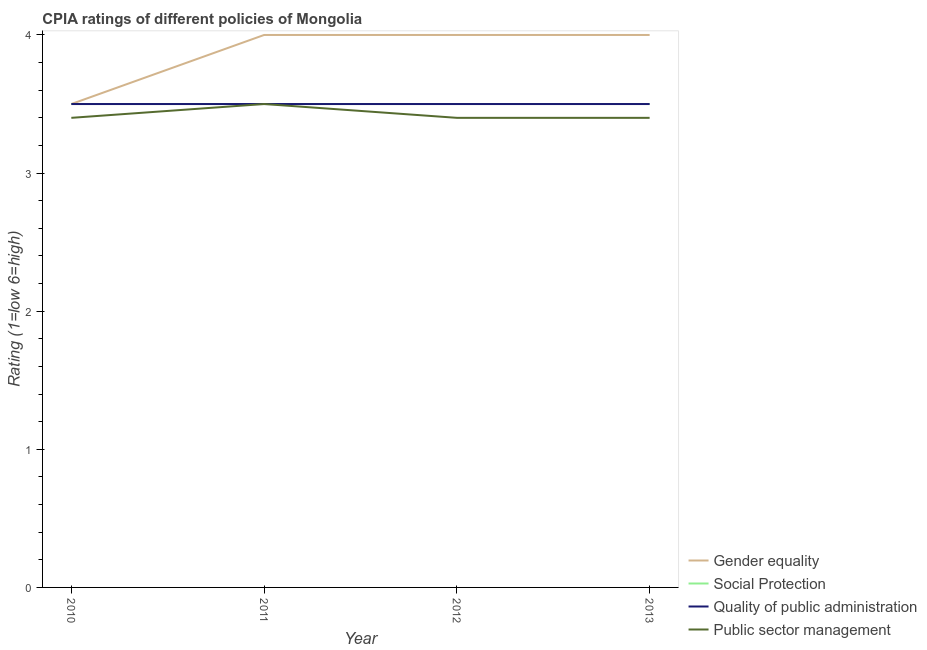How many different coloured lines are there?
Offer a terse response. 4. Across all years, what is the maximum cpia rating of gender equality?
Give a very brief answer. 4. In which year was the cpia rating of public sector management maximum?
Provide a succinct answer. 2011. In which year was the cpia rating of gender equality minimum?
Ensure brevity in your answer.  2010. What is the total cpia rating of gender equality in the graph?
Make the answer very short. 15.5. What is the difference between the cpia rating of public sector management in 2012 and the cpia rating of social protection in 2013?
Offer a terse response. -0.1. In the year 2010, what is the difference between the cpia rating of social protection and cpia rating of quality of public administration?
Your answer should be very brief. 0. What is the difference between the highest and the second highest cpia rating of quality of public administration?
Keep it short and to the point. 0. Is the sum of the cpia rating of public sector management in 2010 and 2013 greater than the maximum cpia rating of gender equality across all years?
Give a very brief answer. Yes. Is it the case that in every year, the sum of the cpia rating of gender equality and cpia rating of social protection is greater than the cpia rating of quality of public administration?
Provide a short and direct response. Yes. Is the cpia rating of social protection strictly greater than the cpia rating of gender equality over the years?
Offer a terse response. No. What is the difference between two consecutive major ticks on the Y-axis?
Your answer should be very brief. 1. Are the values on the major ticks of Y-axis written in scientific E-notation?
Provide a short and direct response. No. Does the graph contain any zero values?
Keep it short and to the point. No. What is the title of the graph?
Make the answer very short. CPIA ratings of different policies of Mongolia. What is the label or title of the X-axis?
Provide a short and direct response. Year. What is the label or title of the Y-axis?
Make the answer very short. Rating (1=low 6=high). What is the Rating (1=low 6=high) in Gender equality in 2010?
Give a very brief answer. 3.5. What is the Rating (1=low 6=high) of Social Protection in 2010?
Provide a short and direct response. 3.5. What is the Rating (1=low 6=high) in Public sector management in 2010?
Keep it short and to the point. 3.4. What is the Rating (1=low 6=high) in Public sector management in 2011?
Make the answer very short. 3.5. What is the Rating (1=low 6=high) in Social Protection in 2012?
Keep it short and to the point. 3.5. What is the Rating (1=low 6=high) in Quality of public administration in 2012?
Offer a terse response. 3.5. What is the Rating (1=low 6=high) of Gender equality in 2013?
Give a very brief answer. 4. What is the Rating (1=low 6=high) of Social Protection in 2013?
Ensure brevity in your answer.  3.5. Across all years, what is the maximum Rating (1=low 6=high) of Gender equality?
Your answer should be compact. 4. Across all years, what is the maximum Rating (1=low 6=high) in Quality of public administration?
Keep it short and to the point. 3.5. Across all years, what is the maximum Rating (1=low 6=high) of Public sector management?
Provide a short and direct response. 3.5. Across all years, what is the minimum Rating (1=low 6=high) of Gender equality?
Ensure brevity in your answer.  3.5. What is the total Rating (1=low 6=high) in Gender equality in the graph?
Ensure brevity in your answer.  15.5. What is the total Rating (1=low 6=high) of Social Protection in the graph?
Your answer should be very brief. 14. What is the total Rating (1=low 6=high) of Quality of public administration in the graph?
Ensure brevity in your answer.  14. What is the total Rating (1=low 6=high) in Public sector management in the graph?
Your answer should be compact. 13.7. What is the difference between the Rating (1=low 6=high) in Social Protection in 2010 and that in 2011?
Give a very brief answer. 0. What is the difference between the Rating (1=low 6=high) in Quality of public administration in 2010 and that in 2011?
Provide a short and direct response. 0. What is the difference between the Rating (1=low 6=high) in Gender equality in 2010 and that in 2012?
Your answer should be very brief. -0.5. What is the difference between the Rating (1=low 6=high) of Social Protection in 2010 and that in 2012?
Your response must be concise. 0. What is the difference between the Rating (1=low 6=high) in Quality of public administration in 2010 and that in 2012?
Ensure brevity in your answer.  0. What is the difference between the Rating (1=low 6=high) in Quality of public administration in 2010 and that in 2013?
Give a very brief answer. 0. What is the difference between the Rating (1=low 6=high) in Gender equality in 2011 and that in 2012?
Make the answer very short. 0. What is the difference between the Rating (1=low 6=high) of Public sector management in 2011 and that in 2012?
Ensure brevity in your answer.  0.1. What is the difference between the Rating (1=low 6=high) of Gender equality in 2011 and that in 2013?
Ensure brevity in your answer.  0. What is the difference between the Rating (1=low 6=high) in Social Protection in 2011 and that in 2013?
Make the answer very short. 0. What is the difference between the Rating (1=low 6=high) in Quality of public administration in 2011 and that in 2013?
Ensure brevity in your answer.  0. What is the difference between the Rating (1=low 6=high) in Public sector management in 2011 and that in 2013?
Your response must be concise. 0.1. What is the difference between the Rating (1=low 6=high) in Social Protection in 2012 and that in 2013?
Your response must be concise. 0. What is the difference between the Rating (1=low 6=high) in Social Protection in 2010 and the Rating (1=low 6=high) in Quality of public administration in 2011?
Offer a terse response. 0. What is the difference between the Rating (1=low 6=high) in Social Protection in 2010 and the Rating (1=low 6=high) in Public sector management in 2011?
Offer a terse response. 0. What is the difference between the Rating (1=low 6=high) of Gender equality in 2010 and the Rating (1=low 6=high) of Social Protection in 2012?
Offer a very short reply. 0. What is the difference between the Rating (1=low 6=high) of Gender equality in 2010 and the Rating (1=low 6=high) of Quality of public administration in 2012?
Provide a succinct answer. 0. What is the difference between the Rating (1=low 6=high) of Social Protection in 2010 and the Rating (1=low 6=high) of Quality of public administration in 2012?
Provide a succinct answer. 0. What is the difference between the Rating (1=low 6=high) in Quality of public administration in 2010 and the Rating (1=low 6=high) in Public sector management in 2012?
Make the answer very short. 0.1. What is the difference between the Rating (1=low 6=high) in Gender equality in 2010 and the Rating (1=low 6=high) in Social Protection in 2013?
Offer a very short reply. 0. What is the difference between the Rating (1=low 6=high) in Gender equality in 2010 and the Rating (1=low 6=high) in Quality of public administration in 2013?
Make the answer very short. 0. What is the difference between the Rating (1=low 6=high) of Social Protection in 2010 and the Rating (1=low 6=high) of Quality of public administration in 2013?
Offer a very short reply. 0. What is the difference between the Rating (1=low 6=high) of Gender equality in 2011 and the Rating (1=low 6=high) of Social Protection in 2012?
Offer a terse response. 0.5. What is the difference between the Rating (1=low 6=high) in Gender equality in 2011 and the Rating (1=low 6=high) in Quality of public administration in 2012?
Offer a terse response. 0.5. What is the difference between the Rating (1=low 6=high) of Social Protection in 2011 and the Rating (1=low 6=high) of Quality of public administration in 2012?
Your response must be concise. 0. What is the difference between the Rating (1=low 6=high) in Quality of public administration in 2011 and the Rating (1=low 6=high) in Public sector management in 2012?
Give a very brief answer. 0.1. What is the difference between the Rating (1=low 6=high) of Gender equality in 2011 and the Rating (1=low 6=high) of Social Protection in 2013?
Make the answer very short. 0.5. What is the difference between the Rating (1=low 6=high) in Gender equality in 2011 and the Rating (1=low 6=high) in Quality of public administration in 2013?
Offer a very short reply. 0.5. What is the difference between the Rating (1=low 6=high) in Quality of public administration in 2011 and the Rating (1=low 6=high) in Public sector management in 2013?
Make the answer very short. 0.1. What is the difference between the Rating (1=low 6=high) in Gender equality in 2012 and the Rating (1=low 6=high) in Social Protection in 2013?
Your answer should be very brief. 0.5. What is the difference between the Rating (1=low 6=high) of Social Protection in 2012 and the Rating (1=low 6=high) of Quality of public administration in 2013?
Your response must be concise. 0. What is the difference between the Rating (1=low 6=high) in Social Protection in 2012 and the Rating (1=low 6=high) in Public sector management in 2013?
Keep it short and to the point. 0.1. What is the difference between the Rating (1=low 6=high) in Quality of public administration in 2012 and the Rating (1=low 6=high) in Public sector management in 2013?
Offer a terse response. 0.1. What is the average Rating (1=low 6=high) of Gender equality per year?
Ensure brevity in your answer.  3.88. What is the average Rating (1=low 6=high) of Social Protection per year?
Your response must be concise. 3.5. What is the average Rating (1=low 6=high) of Quality of public administration per year?
Keep it short and to the point. 3.5. What is the average Rating (1=low 6=high) of Public sector management per year?
Keep it short and to the point. 3.42. In the year 2010, what is the difference between the Rating (1=low 6=high) in Gender equality and Rating (1=low 6=high) in Social Protection?
Offer a very short reply. 0. In the year 2010, what is the difference between the Rating (1=low 6=high) in Gender equality and Rating (1=low 6=high) in Quality of public administration?
Offer a very short reply. 0. In the year 2010, what is the difference between the Rating (1=low 6=high) in Gender equality and Rating (1=low 6=high) in Public sector management?
Offer a terse response. 0.1. In the year 2010, what is the difference between the Rating (1=low 6=high) of Social Protection and Rating (1=low 6=high) of Quality of public administration?
Provide a succinct answer. 0. In the year 2010, what is the difference between the Rating (1=low 6=high) of Quality of public administration and Rating (1=low 6=high) of Public sector management?
Your answer should be very brief. 0.1. In the year 2011, what is the difference between the Rating (1=low 6=high) in Gender equality and Rating (1=low 6=high) in Social Protection?
Offer a very short reply. 0.5. In the year 2011, what is the difference between the Rating (1=low 6=high) in Gender equality and Rating (1=low 6=high) in Quality of public administration?
Provide a short and direct response. 0.5. In the year 2011, what is the difference between the Rating (1=low 6=high) in Gender equality and Rating (1=low 6=high) in Public sector management?
Keep it short and to the point. 0.5. In the year 2011, what is the difference between the Rating (1=low 6=high) in Social Protection and Rating (1=low 6=high) in Public sector management?
Provide a short and direct response. 0. In the year 2012, what is the difference between the Rating (1=low 6=high) of Gender equality and Rating (1=low 6=high) of Social Protection?
Make the answer very short. 0.5. In the year 2012, what is the difference between the Rating (1=low 6=high) of Gender equality and Rating (1=low 6=high) of Quality of public administration?
Provide a succinct answer. 0.5. In the year 2012, what is the difference between the Rating (1=low 6=high) of Social Protection and Rating (1=low 6=high) of Quality of public administration?
Provide a succinct answer. 0. In the year 2012, what is the difference between the Rating (1=low 6=high) in Social Protection and Rating (1=low 6=high) in Public sector management?
Your answer should be compact. 0.1. In the year 2012, what is the difference between the Rating (1=low 6=high) of Quality of public administration and Rating (1=low 6=high) of Public sector management?
Your answer should be very brief. 0.1. In the year 2013, what is the difference between the Rating (1=low 6=high) of Gender equality and Rating (1=low 6=high) of Quality of public administration?
Give a very brief answer. 0.5. In the year 2013, what is the difference between the Rating (1=low 6=high) in Gender equality and Rating (1=low 6=high) in Public sector management?
Provide a short and direct response. 0.6. In the year 2013, what is the difference between the Rating (1=low 6=high) in Social Protection and Rating (1=low 6=high) in Quality of public administration?
Offer a very short reply. 0. In the year 2013, what is the difference between the Rating (1=low 6=high) in Social Protection and Rating (1=low 6=high) in Public sector management?
Offer a very short reply. 0.1. In the year 2013, what is the difference between the Rating (1=low 6=high) of Quality of public administration and Rating (1=low 6=high) of Public sector management?
Give a very brief answer. 0.1. What is the ratio of the Rating (1=low 6=high) of Gender equality in 2010 to that in 2011?
Ensure brevity in your answer.  0.88. What is the ratio of the Rating (1=low 6=high) of Quality of public administration in 2010 to that in 2011?
Ensure brevity in your answer.  1. What is the ratio of the Rating (1=low 6=high) in Public sector management in 2010 to that in 2011?
Your response must be concise. 0.97. What is the ratio of the Rating (1=low 6=high) of Gender equality in 2010 to that in 2013?
Your answer should be compact. 0.88. What is the ratio of the Rating (1=low 6=high) in Public sector management in 2010 to that in 2013?
Provide a short and direct response. 1. What is the ratio of the Rating (1=low 6=high) of Quality of public administration in 2011 to that in 2012?
Your answer should be very brief. 1. What is the ratio of the Rating (1=low 6=high) of Public sector management in 2011 to that in 2012?
Your response must be concise. 1.03. What is the ratio of the Rating (1=low 6=high) in Gender equality in 2011 to that in 2013?
Offer a terse response. 1. What is the ratio of the Rating (1=low 6=high) of Social Protection in 2011 to that in 2013?
Provide a succinct answer. 1. What is the ratio of the Rating (1=low 6=high) of Quality of public administration in 2011 to that in 2013?
Offer a very short reply. 1. What is the ratio of the Rating (1=low 6=high) of Public sector management in 2011 to that in 2013?
Keep it short and to the point. 1.03. What is the ratio of the Rating (1=low 6=high) of Gender equality in 2012 to that in 2013?
Provide a succinct answer. 1. What is the ratio of the Rating (1=low 6=high) in Social Protection in 2012 to that in 2013?
Provide a succinct answer. 1. What is the difference between the highest and the second highest Rating (1=low 6=high) of Public sector management?
Your answer should be very brief. 0.1. What is the difference between the highest and the lowest Rating (1=low 6=high) of Social Protection?
Offer a very short reply. 0. What is the difference between the highest and the lowest Rating (1=low 6=high) of Quality of public administration?
Offer a terse response. 0. What is the difference between the highest and the lowest Rating (1=low 6=high) of Public sector management?
Offer a terse response. 0.1. 